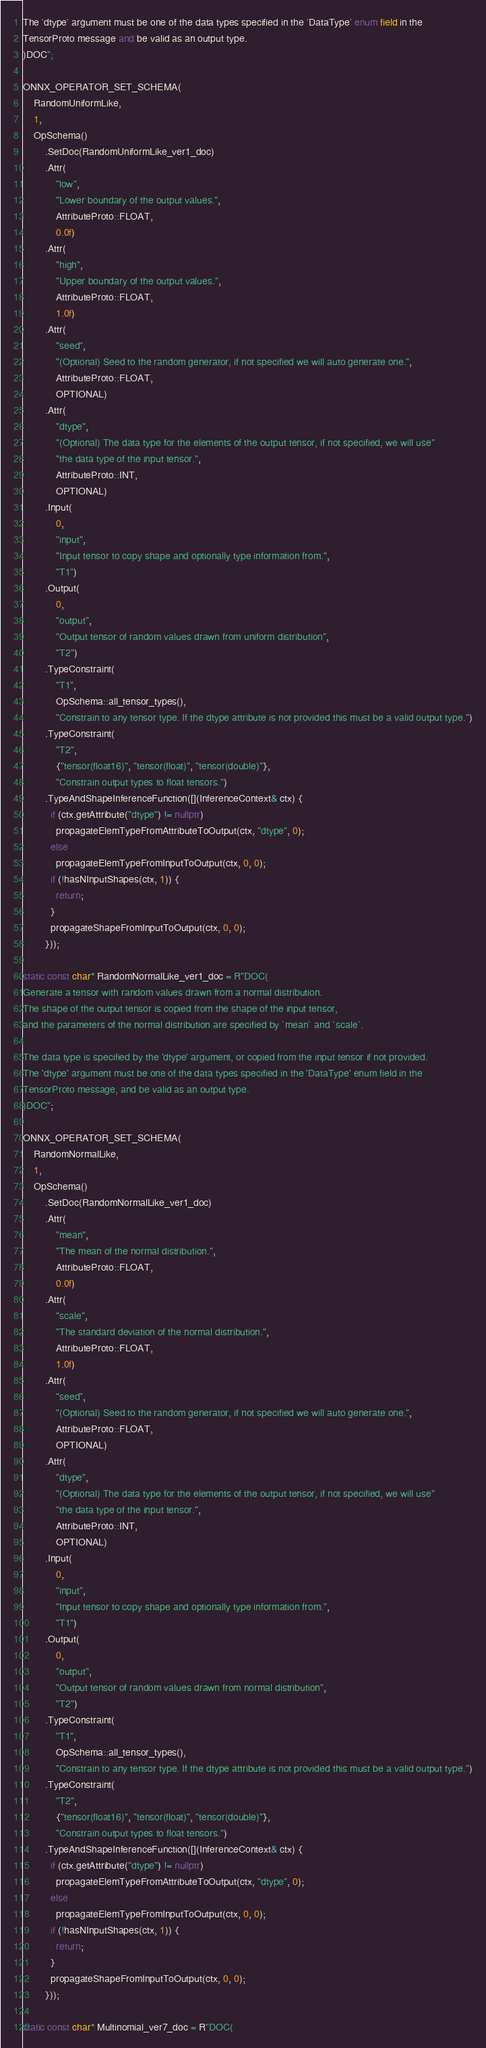<code> <loc_0><loc_0><loc_500><loc_500><_C++_>The 'dtype' argument must be one of the data types specified in the 'DataType' enum field in the
TensorProto message and be valid as an output type.
)DOC";

ONNX_OPERATOR_SET_SCHEMA(
    RandomUniformLike,
    1,
    OpSchema()
        .SetDoc(RandomUniformLike_ver1_doc)
        .Attr(
            "low",
            "Lower boundary of the output values.",
            AttributeProto::FLOAT,
            0.0f)
        .Attr(
            "high",
            "Upper boundary of the output values.",
            AttributeProto::FLOAT,
            1.0f)
        .Attr(
            "seed",
            "(Optional) Seed to the random generator, if not specified we will auto generate one.",
            AttributeProto::FLOAT,
            OPTIONAL)
        .Attr(
            "dtype",
            "(Optional) The data type for the elements of the output tensor, if not specified, we will use"
            "the data type of the input tensor.",
            AttributeProto::INT,
            OPTIONAL)
        .Input(
            0,
            "input",
            "Input tensor to copy shape and optionally type information from.",
            "T1")
        .Output(
            0,
            "output",
            "Output tensor of random values drawn from uniform distribution",
            "T2")
        .TypeConstraint(
            "T1",
            OpSchema::all_tensor_types(),
            "Constrain to any tensor type. If the dtype attribute is not provided this must be a valid output type.")
        .TypeConstraint(
            "T2",
            {"tensor(float16)", "tensor(float)", "tensor(double)"},
            "Constrain output types to float tensors.")
        .TypeAndShapeInferenceFunction([](InferenceContext& ctx) {
          if (ctx.getAttribute("dtype") != nullptr)
            propagateElemTypeFromAttributeToOutput(ctx, "dtype", 0);
          else
            propagateElemTypeFromInputToOutput(ctx, 0, 0);
          if (!hasNInputShapes(ctx, 1)) {
            return;
          }
          propagateShapeFromInputToOutput(ctx, 0, 0);
        }));

static const char* RandomNormalLike_ver1_doc = R"DOC(
Generate a tensor with random values drawn from a normal distribution.
The shape of the output tensor is copied from the shape of the input tensor,
and the parameters of the normal distribution are specified by `mean` and `scale`.

The data type is specified by the 'dtype' argument, or copied from the input tensor if not provided.
The 'dtype' argument must be one of the data types specified in the 'DataType' enum field in the
TensorProto message, and be valid as an output type.
)DOC";

ONNX_OPERATOR_SET_SCHEMA(
    RandomNormalLike,
    1,
    OpSchema()
        .SetDoc(RandomNormalLike_ver1_doc)
        .Attr(
            "mean",
            "The mean of the normal distribution.",
            AttributeProto::FLOAT,
            0.0f)
        .Attr(
            "scale",
            "The standard deviation of the normal distribution.",
            AttributeProto::FLOAT,
            1.0f)
        .Attr(
            "seed",
            "(Optional) Seed to the random generator, if not specified we will auto generate one.",
            AttributeProto::FLOAT,
            OPTIONAL)
        .Attr(
            "dtype",
            "(Optional) The data type for the elements of the output tensor, if not specified, we will use"
            "the data type of the input tensor.",
            AttributeProto::INT,
            OPTIONAL)
        .Input(
            0,
            "input",
            "Input tensor to copy shape and optionally type information from.",
            "T1")
        .Output(
            0,
            "output",
            "Output tensor of random values drawn from normal distribution",
            "T2")
        .TypeConstraint(
            "T1",
            OpSchema::all_tensor_types(),
            "Constrain to any tensor type. If the dtype attribute is not provided this must be a valid output type.")
        .TypeConstraint(
            "T2",
            {"tensor(float16)", "tensor(float)", "tensor(double)"},
            "Constrain output types to float tensors.")
        .TypeAndShapeInferenceFunction([](InferenceContext& ctx) {
          if (ctx.getAttribute("dtype") != nullptr)
            propagateElemTypeFromAttributeToOutput(ctx, "dtype", 0);
          else
            propagateElemTypeFromInputToOutput(ctx, 0, 0);
          if (!hasNInputShapes(ctx, 1)) {
            return;
          }
          propagateShapeFromInputToOutput(ctx, 0, 0);
        }));

static const char* Multinomial_ver7_doc = R"DOC(</code> 